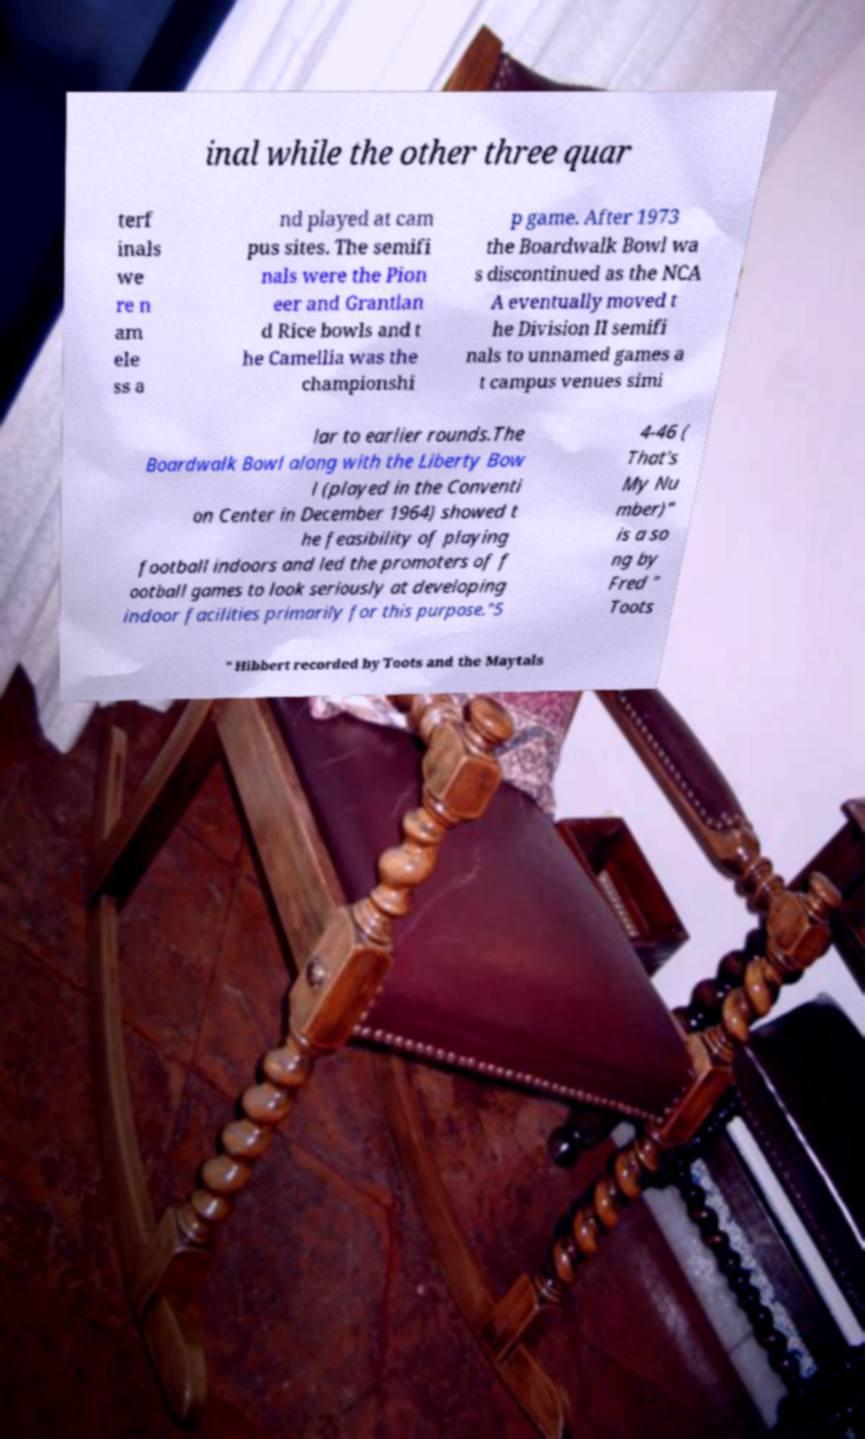Could you assist in decoding the text presented in this image and type it out clearly? inal while the other three quar terf inals we re n am ele ss a nd played at cam pus sites. The semifi nals were the Pion eer and Grantlan d Rice bowls and t he Camellia was the championshi p game. After 1973 the Boardwalk Bowl wa s discontinued as the NCA A eventually moved t he Division II semifi nals to unnamed games a t campus venues simi lar to earlier rounds.The Boardwalk Bowl along with the Liberty Bow l (played in the Conventi on Center in December 1964) showed t he feasibility of playing football indoors and led the promoters of f ootball games to look seriously at developing indoor facilities primarily for this purpose."5 4-46 ( That's My Nu mber)" is a so ng by Fred " Toots " Hibbert recorded by Toots and the Maytals 